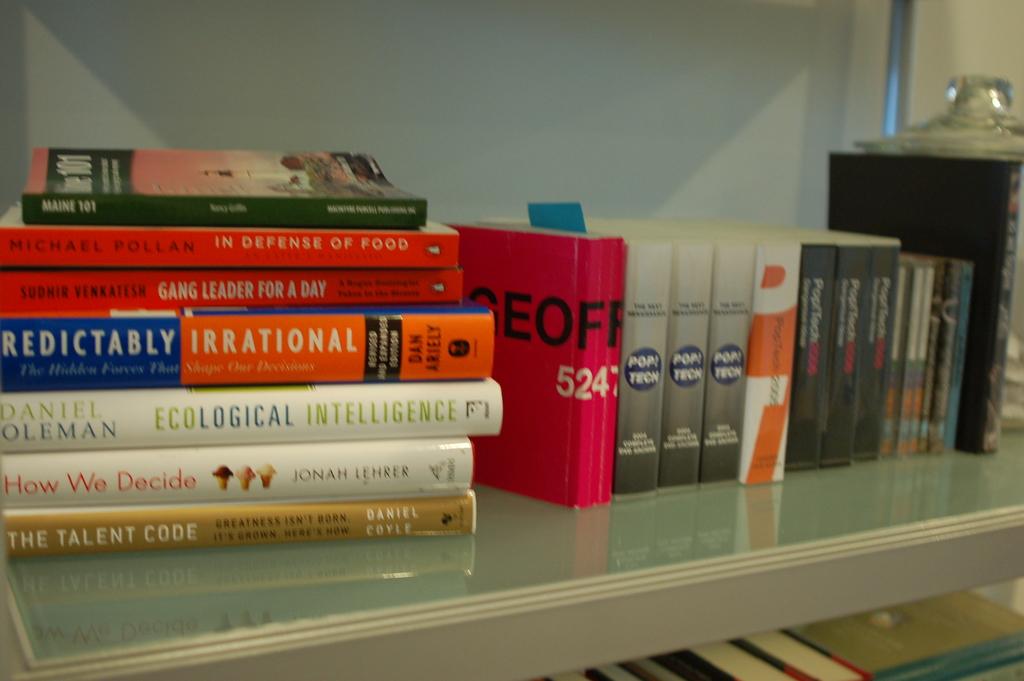What number is on the pink cover book?
Your answer should be compact. 524. 